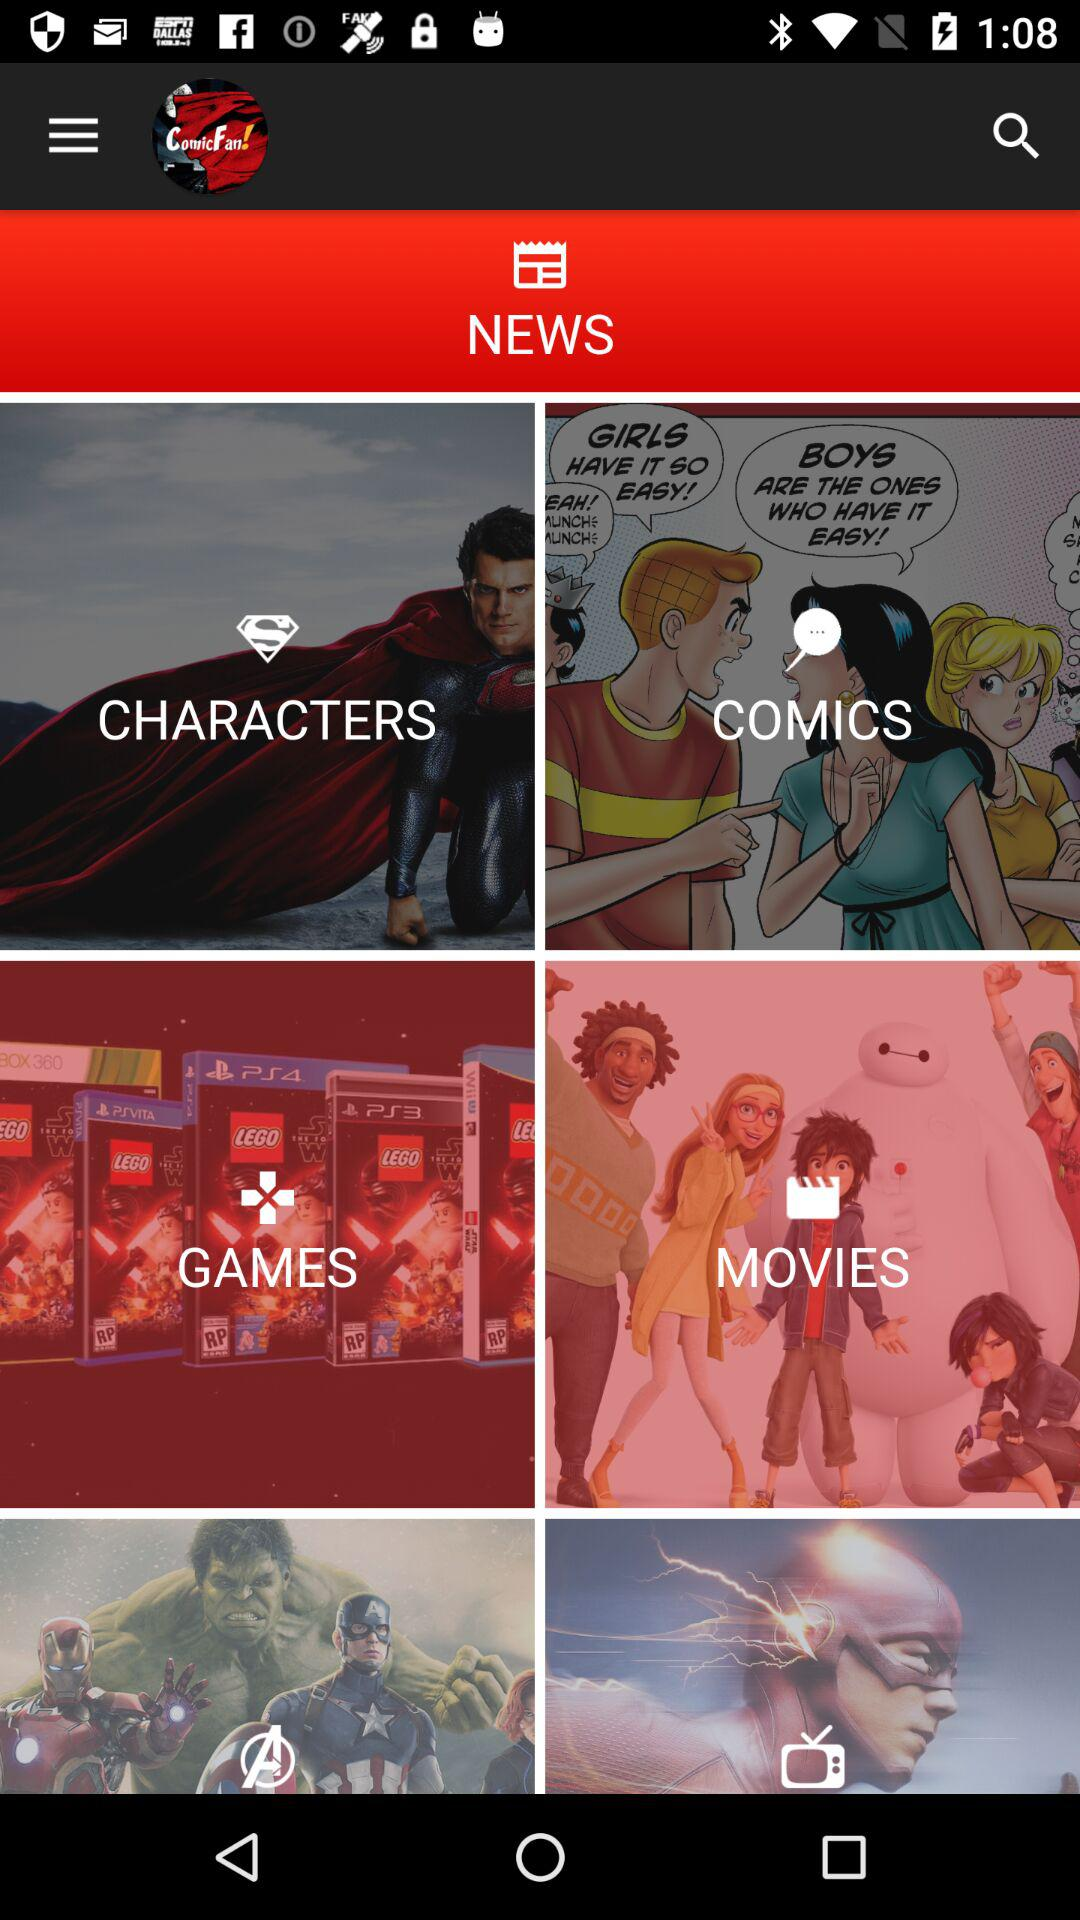What is the name of the application? The name of the application is "ComicFan!". 